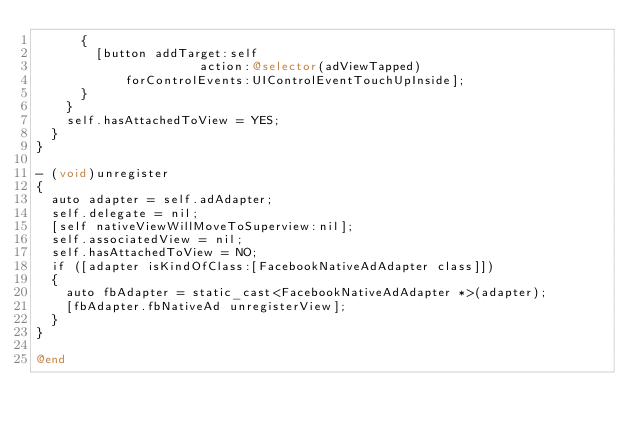<code> <loc_0><loc_0><loc_500><loc_500><_ObjectiveC_>      {
        [button addTarget:self
                      action:@selector(adViewTapped)
            forControlEvents:UIControlEventTouchUpInside];
      }
    }
    self.hasAttachedToView = YES;
  }
}

- (void)unregister
{
  auto adapter = self.adAdapter;
  self.delegate = nil;
  [self nativeViewWillMoveToSuperview:nil];
  self.associatedView = nil;
  self.hasAttachedToView = NO;
  if ([adapter isKindOfClass:[FacebookNativeAdAdapter class]])
  {
    auto fbAdapter = static_cast<FacebookNativeAdAdapter *>(adapter);
    [fbAdapter.fbNativeAd unregisterView];
  }
}

@end
</code> 